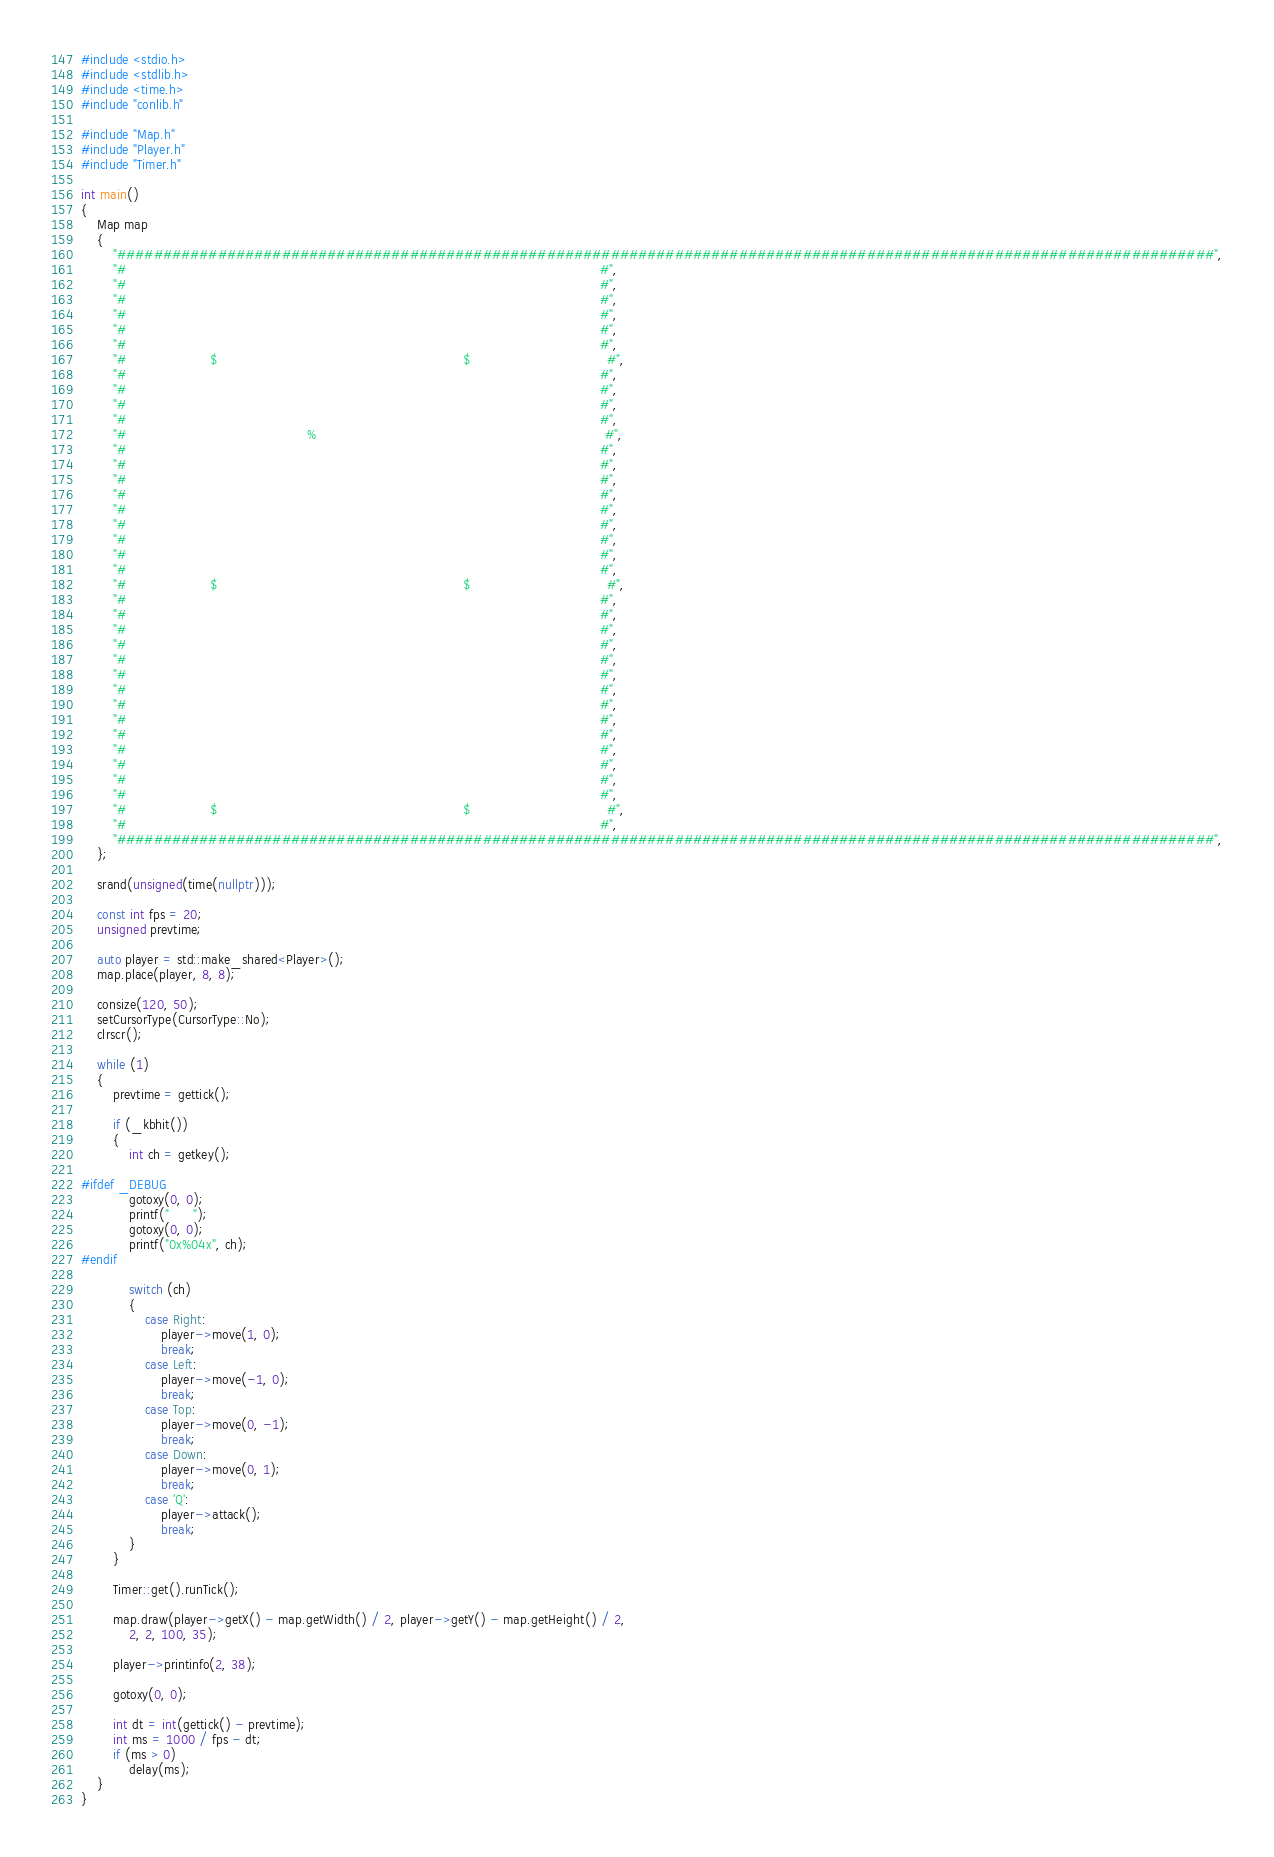Convert code to text. <code><loc_0><loc_0><loc_500><loc_500><_C++_>#include <stdio.h>
#include <stdlib.h>
#include <time.h>
#include "conlib.h"

#include "Map.h"
#include "Player.h"
#include "Timer.h"

int main()
{
    Map map
    {
        "########################################################################################################################",
        "#                                                                                                                      #",
        "#                                                                                                                      #",
        "#                                                                                                                      #",
        "#                                                                                                                      #",
        "#                                                                                                                      #",
        "#                                                                                                                      #",
        "#                     $                                                             $                                  #",
        "#                                                                                                                      #",
        "#                                                                                                                      #",
        "#                                                                                                                      #",
        "#                                                                                                                      #",
        "#                                             %                                                                        #",
        "#                                                                                                                      #",
        "#                                                                                                                      #",
        "#                                                                                                                      #",
        "#                                                                                                                      #",
        "#                                                                                                                      #",
        "#                                                                                                                      #",
        "#                                                                                                                      #",
        "#                                                                                                                      #",
        "#                                                                                                                      #",
        "#                     $                                                             $                                  #",
        "#                                                                                                                      #",
        "#                                                                                                                      #",
        "#                                                                                                                      #",
        "#                                                                                                                      #",
        "#                                                                                                                      #",
        "#                                                                                                                      #",
        "#                                                                                                                      #",
        "#                                                                                                                      #",
        "#                                                                                                                      #",
        "#                                                                                                                      #",
        "#                                                                                                                      #",
        "#                                                                                                                      #",
        "#                                                                                                                      #",
        "#                                                                                                                      #",
        "#                     $                                                             $                                  #",
        "#                                                                                                                      #",
        "########################################################################################################################",
    };

    srand(unsigned(time(nullptr)));

    const int fps = 20;
    unsigned prevtime;

    auto player = std::make_shared<Player>();
    map.place(player, 8, 8);

    consize(120, 50);
    setCursorType(CursorType::No);
    clrscr();

    while (1)
    {
        prevtime = gettick();

        if (_kbhit())
        {
            int ch = getkey();

#ifdef _DEBUG
            gotoxy(0, 0);
            printf("      ");
            gotoxy(0, 0);
            printf("0x%04x", ch);
#endif

            switch (ch)
            {
                case Right:
                    player->move(1, 0);
                    break;
                case Left:
                    player->move(-1, 0);
                    break;
                case Top:
                    player->move(0, -1);
                    break;
                case Down:
                    player->move(0, 1);
                    break;
                case 'Q':
                    player->attack();
                    break;
            }
        }

        Timer::get().runTick();

        map.draw(player->getX() - map.getWidth() / 2, player->getY() - map.getHeight() / 2,
            2, 2, 100, 35);

        player->printinfo(2, 38);

        gotoxy(0, 0);

        int dt = int(gettick() - prevtime);
        int ms = 1000 / fps - dt;
        if (ms > 0)
            delay(ms);
    }
}
</code> 